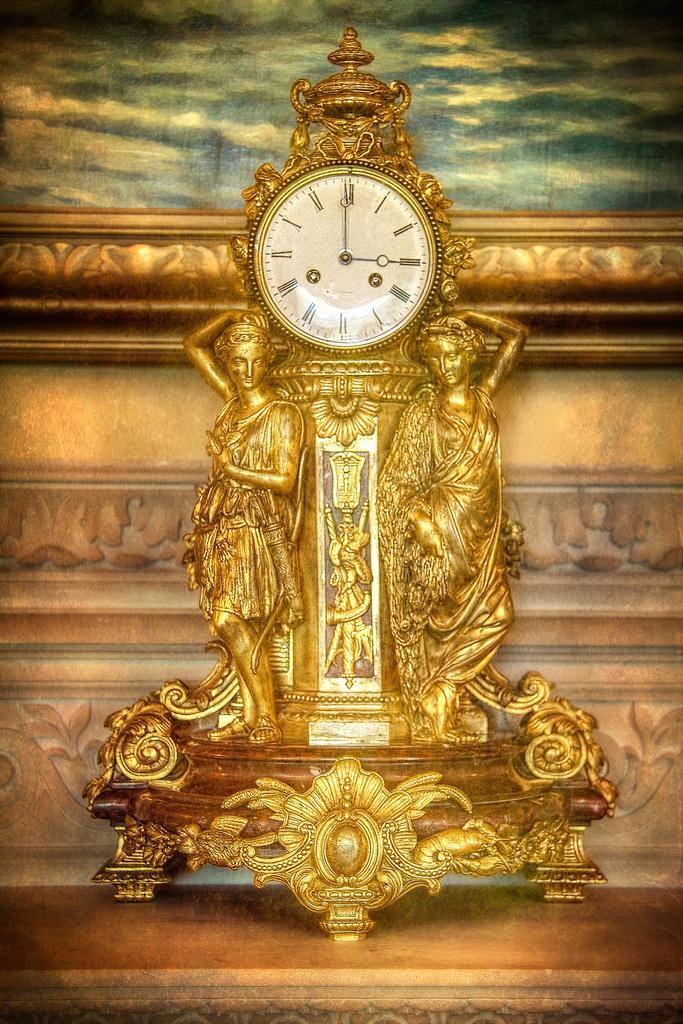Describe this image in one or two sentences. In the image in the center, we can see one table. On the table, we can see one clock and sculptures. In the background there is a wall and a photo frame. 